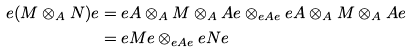<formula> <loc_0><loc_0><loc_500><loc_500>e ( M \otimes _ { A } N ) e & = e A \otimes _ { A } M \otimes _ { A } A e \otimes _ { e A e } e A \otimes _ { A } M \otimes _ { A } A e \\ & = e M e \otimes _ { e A e } e N e</formula> 